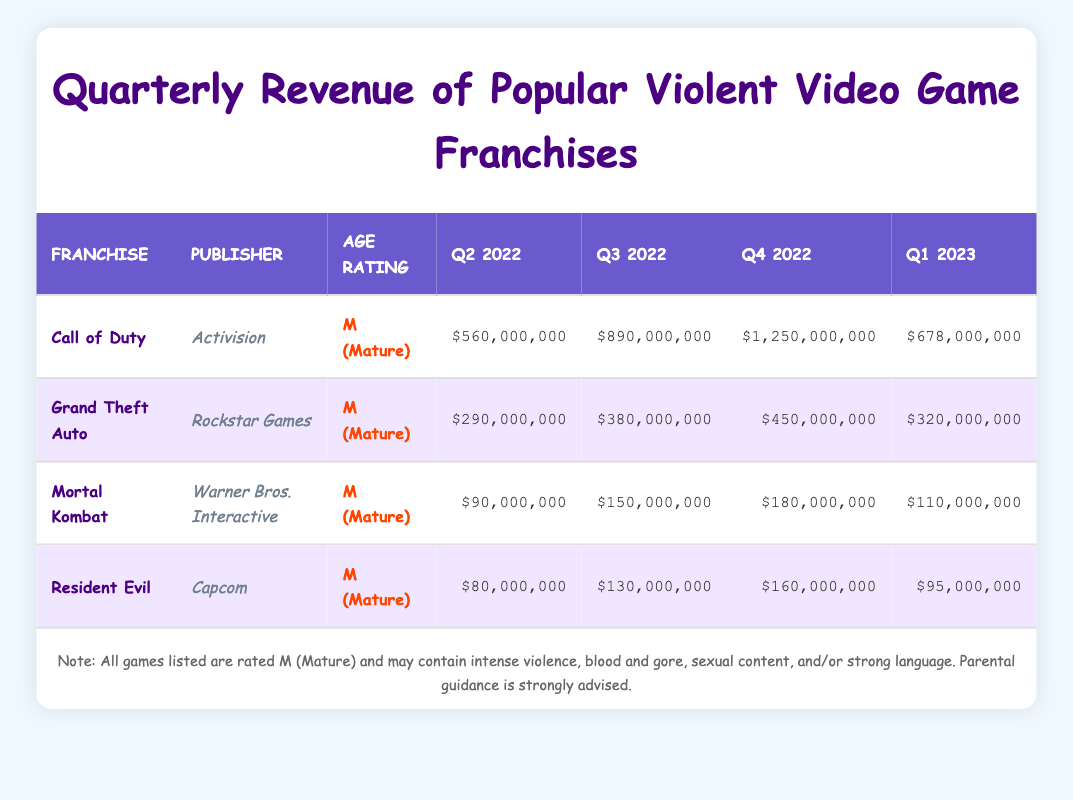What is the total revenue generated by Call of Duty in Q4 2022? The revenue for Call of Duty in Q4 2022 is listed as $1,250,000,000. Therefore, the total revenue for that quarter is simply that amount.
Answer: $1,250,000,000 Which game had the highest revenue in Q3 2022? In the Q3 2022 column, Call of Duty has revenue of $890,000,000, Grand Theft Auto has $380,000,000, Mortal Kombat has $150,000,000, and Resident Evil has $130,000,000. The highest among these is Call of Duty at $890,000,000.
Answer: Call of Duty What is the difference in revenue between Mortal Kombat in Q1 2023 and Q4 2022? The revenue for Mortal Kombat in Q1 2023 is $110,000,000 and in Q4 2022 is $180,000,000. The difference is calculated as $180,000,000 - $110,000,000 = $70,000,000.
Answer: $70,000,000 Is the revenue for Resident Evil in Q2 2022 greater than that of Mortal Kombat in the same quarter? Resident Evil's revenue in Q2 2022 is $80,000,000, while Mortal Kombat's revenue is $90,000,000. Since $80,000,000 is less than $90,000,000, the statement is false.
Answer: No What is the average revenue for Grand Theft Auto across all quarters listed? The revenues for Grand Theft Auto are $290,000,000 (Q2 2022), $380,000,000 (Q3 2022), $450,000,000 (Q4 2022), and $320,000,000 (Q1 2023). The total revenue is $290,000,000 + $380,000,000 + $450,000,000 + $320,000,000 = $1,440,000,000. To get the average, divide the total by 4, which gives $1,440,000,000 / 4 = $360,000,000.
Answer: $360,000,000 Which franchise had the lowest revenue in Q1 2023? The revenues in Q1 2023 are Call of Duty at $678,000,000, Grand Theft Auto at $320,000,000, Mortal Kombat at $110,000,000, and Resident Evil at $95,000,000. Among these, Resident Evil has the lowest revenue at $95,000,000.
Answer: Resident Evil What is the sum of revenues for all franchises in Q2 2022? The revenues in Q2 2022 are: Call of Duty $560,000,000, Grand Theft Auto $290,000,000, Mortal Kombat $90,000,000, and Resident Evil $80,000,000. The sum is $560,000,000 + $290,000,000 + $90,000,000 + $80,000,000 = $1,020,000,000.
Answer: $1,020,000,000 How many franchises are listed in the table? There are four franchises listed in the table: Call of Duty, Grand Theft Auto, Mortal Kombat, and Resident Evil. Therefore, the count is four.
Answer: 4 